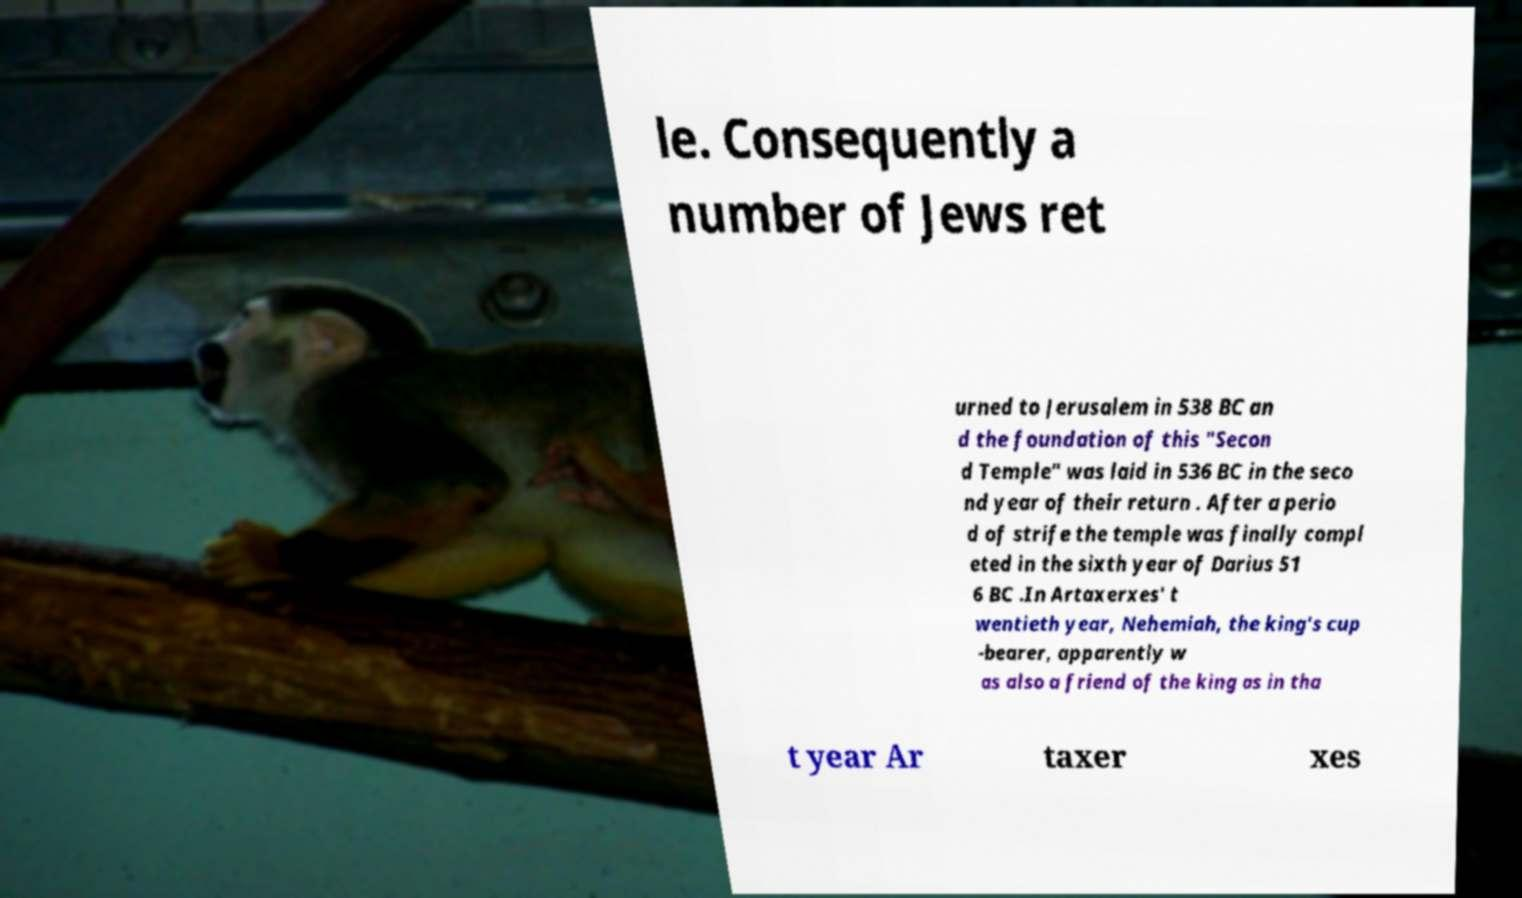There's text embedded in this image that I need extracted. Can you transcribe it verbatim? le. Consequently a number of Jews ret urned to Jerusalem in 538 BC an d the foundation of this "Secon d Temple" was laid in 536 BC in the seco nd year of their return . After a perio d of strife the temple was finally compl eted in the sixth year of Darius 51 6 BC .In Artaxerxes' t wentieth year, Nehemiah, the king's cup -bearer, apparently w as also a friend of the king as in tha t year Ar taxer xes 